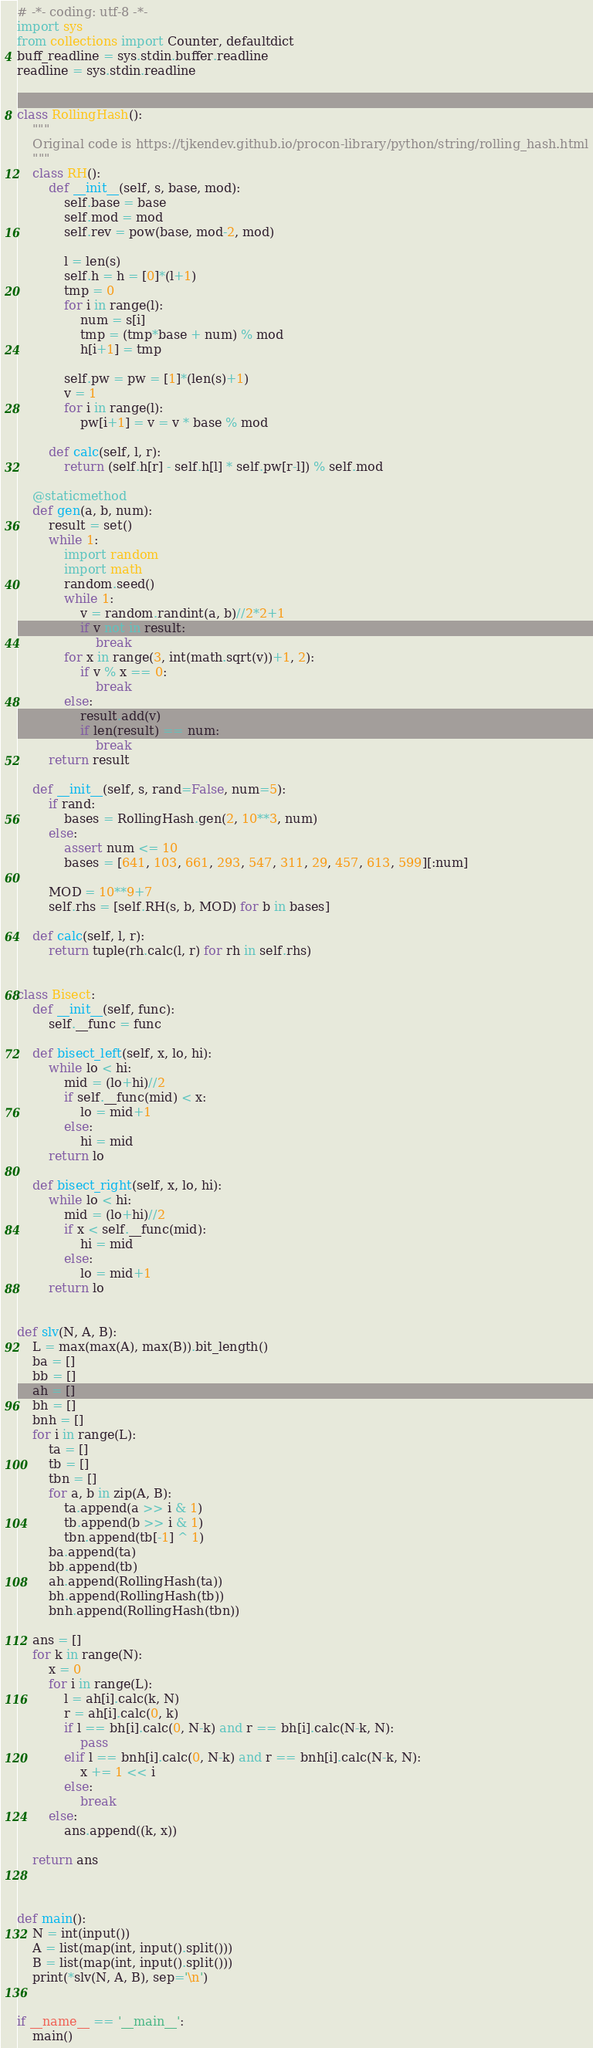<code> <loc_0><loc_0><loc_500><loc_500><_Python_># -*- coding: utf-8 -*-
import sys
from collections import Counter, defaultdict
buff_readline = sys.stdin.buffer.readline
readline = sys.stdin.readline


class RollingHash():
    """
    Original code is https://tjkendev.github.io/procon-library/python/string/rolling_hash.html
    """
    class RH():
        def __init__(self, s, base, mod):
            self.base = base
            self.mod = mod
            self.rev = pow(base, mod-2, mod)

            l = len(s)
            self.h = h = [0]*(l+1)
            tmp = 0
            for i in range(l):
                num = s[i]
                tmp = (tmp*base + num) % mod
                h[i+1] = tmp

            self.pw = pw = [1]*(len(s)+1)
            v = 1
            for i in range(l):
                pw[i+1] = v = v * base % mod

        def calc(self, l, r):
            return (self.h[r] - self.h[l] * self.pw[r-l]) % self.mod

    @staticmethod
    def gen(a, b, num):
        result = set()
        while 1:
            import random
            import math
            random.seed()
            while 1:
                v = random.randint(a, b)//2*2+1
                if v not in result:
                    break
            for x in range(3, int(math.sqrt(v))+1, 2):
                if v % x == 0:
                    break
            else:
                result.add(v)
                if len(result) == num:
                    break
        return result

    def __init__(self, s, rand=False, num=5):
        if rand:
            bases = RollingHash.gen(2, 10**3, num)
        else:
            assert num <= 10
            bases = [641, 103, 661, 293, 547, 311, 29, 457, 613, 599][:num]

        MOD = 10**9+7
        self.rhs = [self.RH(s, b, MOD) for b in bases]

    def calc(self, l, r):
        return tuple(rh.calc(l, r) for rh in self.rhs)


class Bisect:
    def __init__(self, func):
        self.__func = func

    def bisect_left(self, x, lo, hi):
        while lo < hi:
            mid = (lo+hi)//2
            if self.__func(mid) < x:
                lo = mid+1
            else:
                hi = mid
        return lo

    def bisect_right(self, x, lo, hi):
        while lo < hi:
            mid = (lo+hi)//2
            if x < self.__func(mid):
                hi = mid
            else:
                lo = mid+1
        return lo


def slv(N, A, B):
    L = max(max(A), max(B)).bit_length()
    ba = []
    bb = []
    ah = []
    bh = []
    bnh = []
    for i in range(L):
        ta = []
        tb = []
        tbn = []
        for a, b in zip(A, B):
            ta.append(a >> i & 1)
            tb.append(b >> i & 1)
            tbn.append(tb[-1] ^ 1)
        ba.append(ta)
        bb.append(tb)
        ah.append(RollingHash(ta))
        bh.append(RollingHash(tb))
        bnh.append(RollingHash(tbn))

    ans = []
    for k in range(N):
        x = 0
        for i in range(L):
            l = ah[i].calc(k, N)
            r = ah[i].calc(0, k)
            if l == bh[i].calc(0, N-k) and r == bh[i].calc(N-k, N):
                pass
            elif l == bnh[i].calc(0, N-k) and r == bnh[i].calc(N-k, N):
                x += 1 << i
            else:
                break
        else:
            ans.append((k, x))

    return ans



def main():
    N = int(input())
    A = list(map(int, input().split()))
    B = list(map(int, input().split()))
    print(*slv(N, A, B), sep='\n')


if __name__ == '__main__':
    main()
</code> 